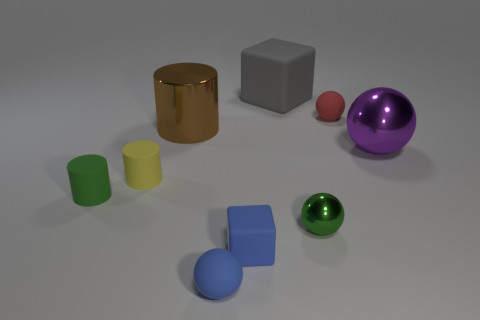There is a small sphere that is behind the big purple sphere; what material is it?
Provide a short and direct response. Rubber. What is the size of the blue ball that is the same material as the tiny cube?
Keep it short and to the point. Small. There is a green matte cylinder; are there any red things in front of it?
Offer a very short reply. No. There is another rubber thing that is the same shape as the gray rubber object; what is its size?
Ensure brevity in your answer.  Small. Is the color of the small metal thing the same as the tiny sphere that is left of the blue block?
Ensure brevity in your answer.  No. Does the small shiny thing have the same color as the big shiny cylinder?
Offer a very short reply. No. Is the number of tiny blue objects less than the number of yellow rubber objects?
Keep it short and to the point. No. How many other things are there of the same color as the big matte thing?
Keep it short and to the point. 0. How many brown matte things are there?
Offer a terse response. 0. Are there fewer small rubber cubes that are behind the small green metal thing than big cyan objects?
Provide a succinct answer. No. 